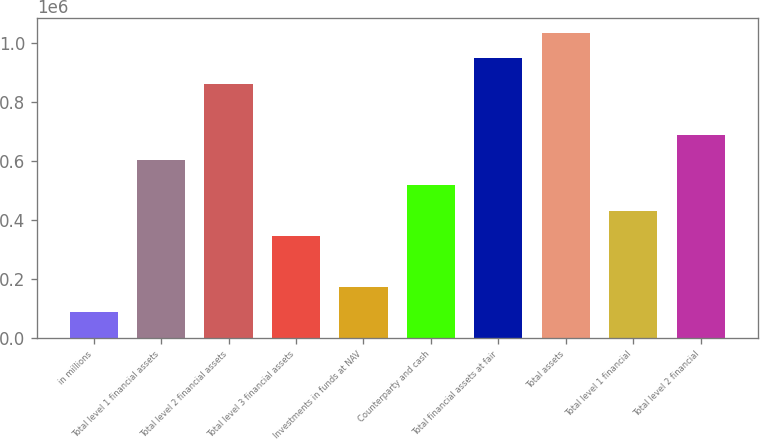Convert chart to OTSL. <chart><loc_0><loc_0><loc_500><loc_500><bar_chart><fcel>in millions<fcel>Total level 1 financial assets<fcel>Total level 2 financial assets<fcel>Total level 3 financial assets<fcel>Investments in funds at NAV<fcel>Counterparty and cash<fcel>Total financial assets at fair<fcel>Total assets<fcel>Total level 1 financial<fcel>Total level 2 financial<nl><fcel>86144.9<fcel>602978<fcel>861395<fcel>344562<fcel>172284<fcel>516839<fcel>947534<fcel>1.03367e+06<fcel>430700<fcel>689117<nl></chart> 